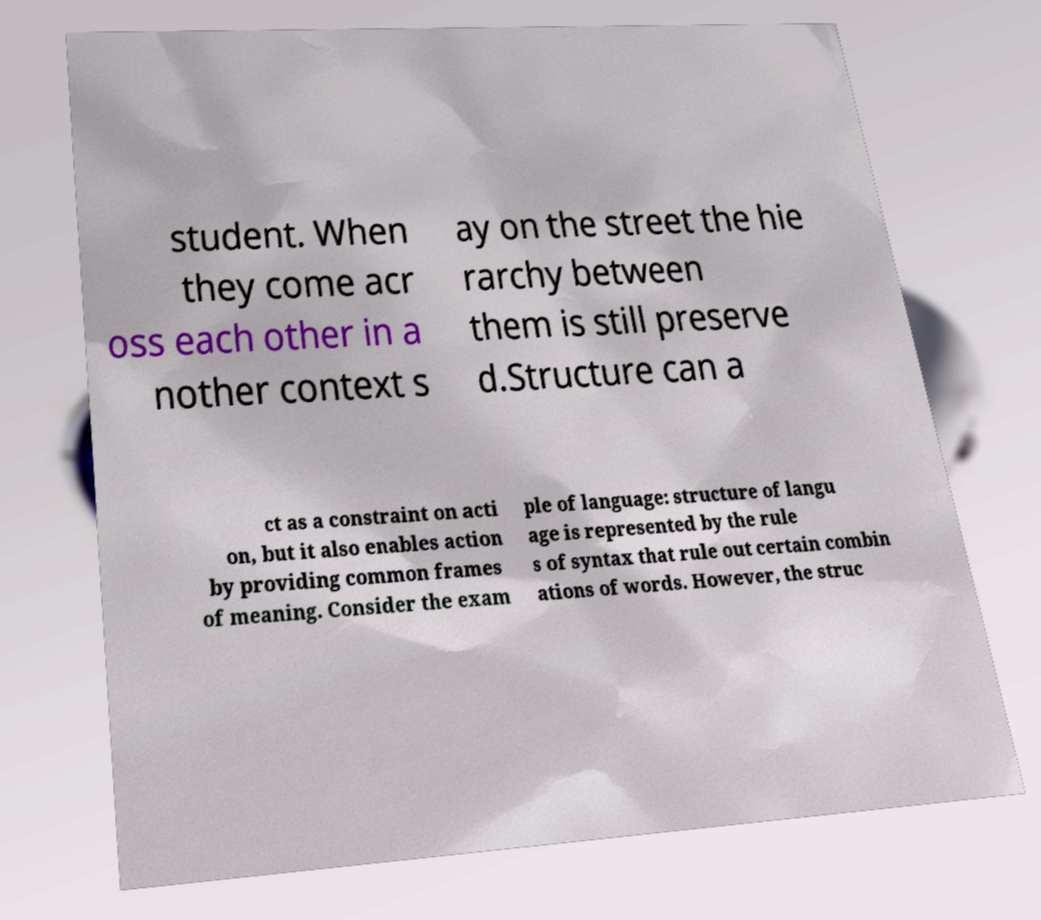Could you extract and type out the text from this image? student. When they come acr oss each other in a nother context s ay on the street the hie rarchy between them is still preserve d.Structure can a ct as a constraint on acti on, but it also enables action by providing common frames of meaning. Consider the exam ple of language: structure of langu age is represented by the rule s of syntax that rule out certain combin ations of words. However, the struc 